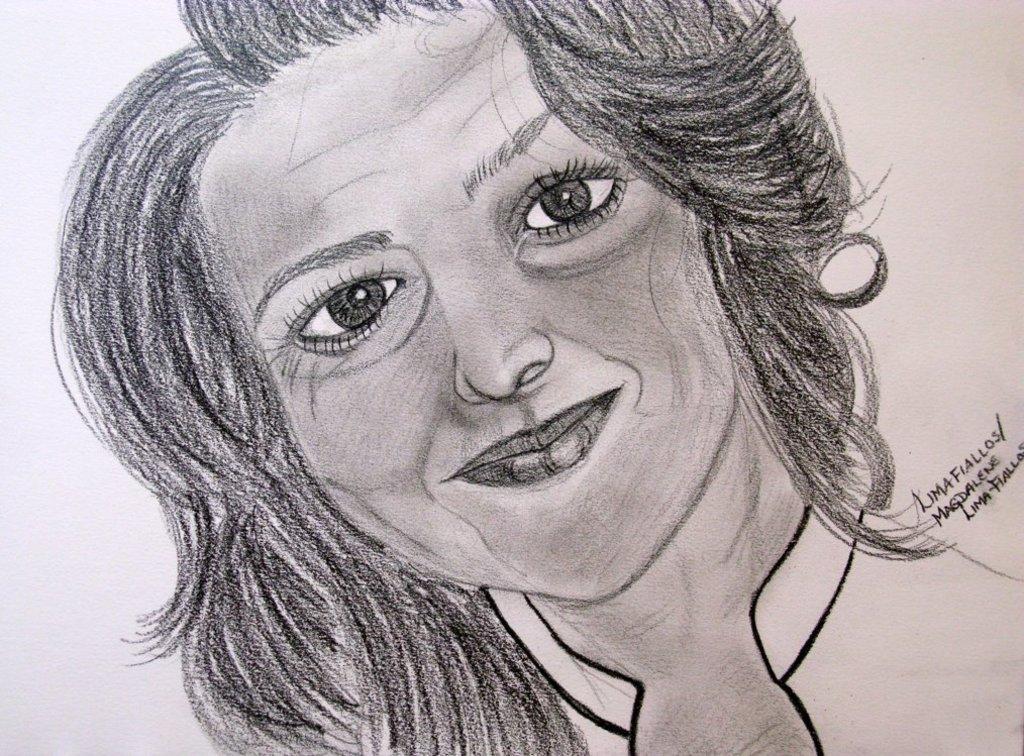Could you give a brief overview of what you see in this image? In this image there is a drawing of a girl and there is some text at the right side of the image. 